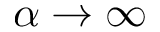<formula> <loc_0><loc_0><loc_500><loc_500>\alpha \rightarrow \infty</formula> 